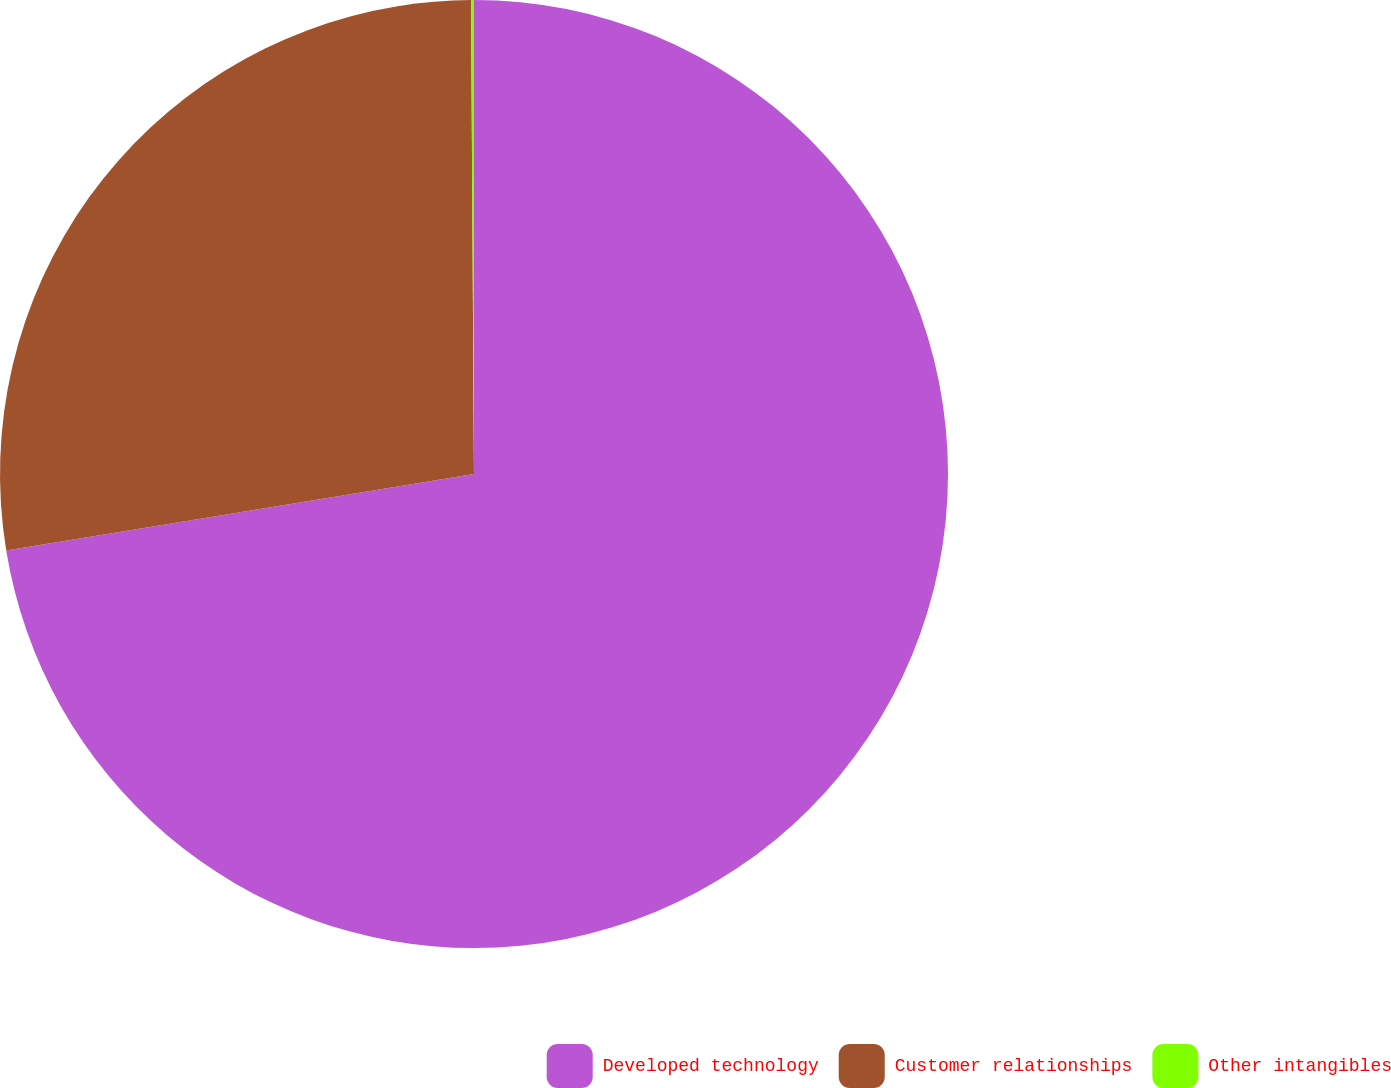Convert chart to OTSL. <chart><loc_0><loc_0><loc_500><loc_500><pie_chart><fcel>Developed technology<fcel>Customer relationships<fcel>Other intangibles<nl><fcel>72.42%<fcel>27.48%<fcel>0.1%<nl></chart> 